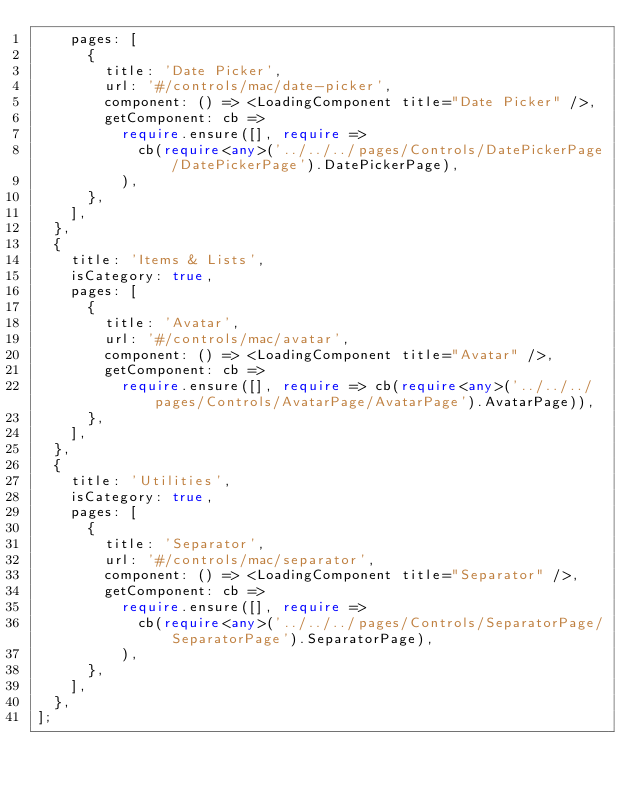<code> <loc_0><loc_0><loc_500><loc_500><_TypeScript_>    pages: [
      {
        title: 'Date Picker',
        url: '#/controls/mac/date-picker',
        component: () => <LoadingComponent title="Date Picker" />,
        getComponent: cb =>
          require.ensure([], require =>
            cb(require<any>('../../../pages/Controls/DatePickerPage/DatePickerPage').DatePickerPage),
          ),
      },
    ],
  },
  {
    title: 'Items & Lists',
    isCategory: true,
    pages: [
      {
        title: 'Avatar',
        url: '#/controls/mac/avatar',
        component: () => <LoadingComponent title="Avatar" />,
        getComponent: cb =>
          require.ensure([], require => cb(require<any>('../../../pages/Controls/AvatarPage/AvatarPage').AvatarPage)),
      },
    ],
  },
  {
    title: 'Utilities',
    isCategory: true,
    pages: [
      {
        title: 'Separator',
        url: '#/controls/mac/separator',
        component: () => <LoadingComponent title="Separator" />,
        getComponent: cb =>
          require.ensure([], require =>
            cb(require<any>('../../../pages/Controls/SeparatorPage/SeparatorPage').SeparatorPage),
          ),
      },
    ],
  },
];
</code> 